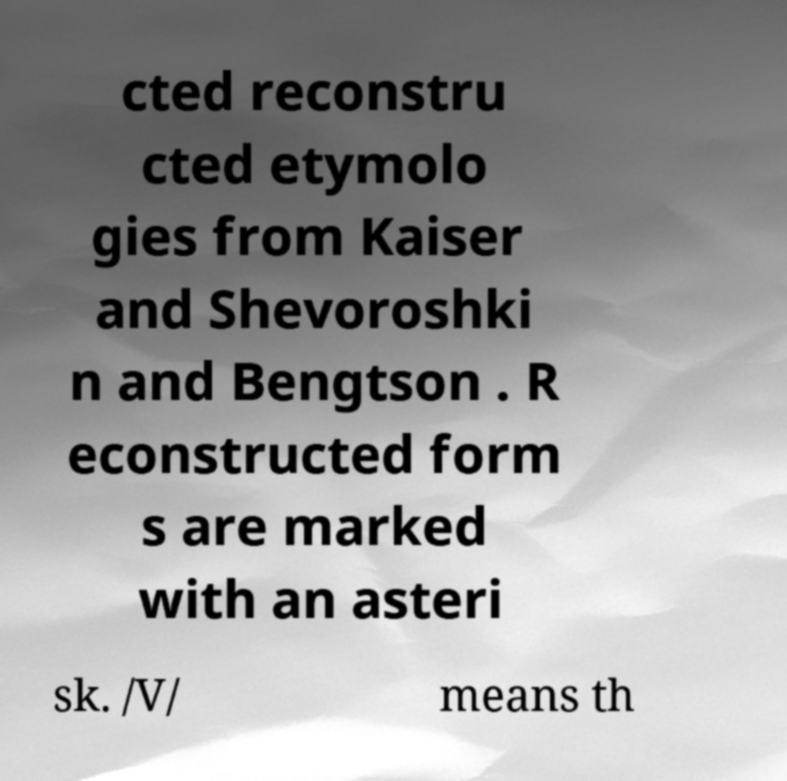Could you extract and type out the text from this image? cted reconstru cted etymolo gies from Kaiser and Shevoroshki n and Bengtson . R econstructed form s are marked with an asteri sk. /V/ means th 